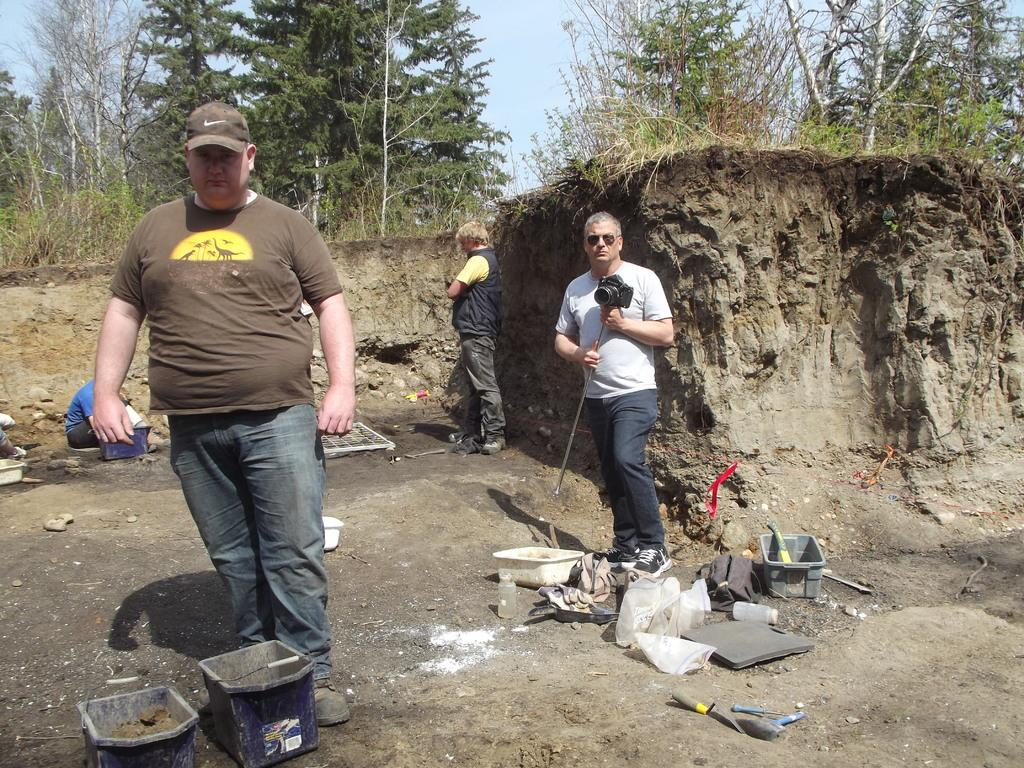How many people are standing in the image? There are three people standing in the image. What is the position of the fourth person in the image? There is a person sitting in the image. What is the man holding in the image? The man is holding a camera in the image. What can be seen in the image that might be used for carrying water or other liquids? There are buckets visible in the image. What objects are present on a surface in the image? There are objects on a surface in the image, but the specific objects are not mentioned in the facts. What is visible in the background of the image? There are trees and the sky visible in the background of the image. What type of pets are visible in the image? There are no pets visible in the image. What is the border between the trees and the sky in the image? The facts do not mention a border between the trees and the sky in the image. 